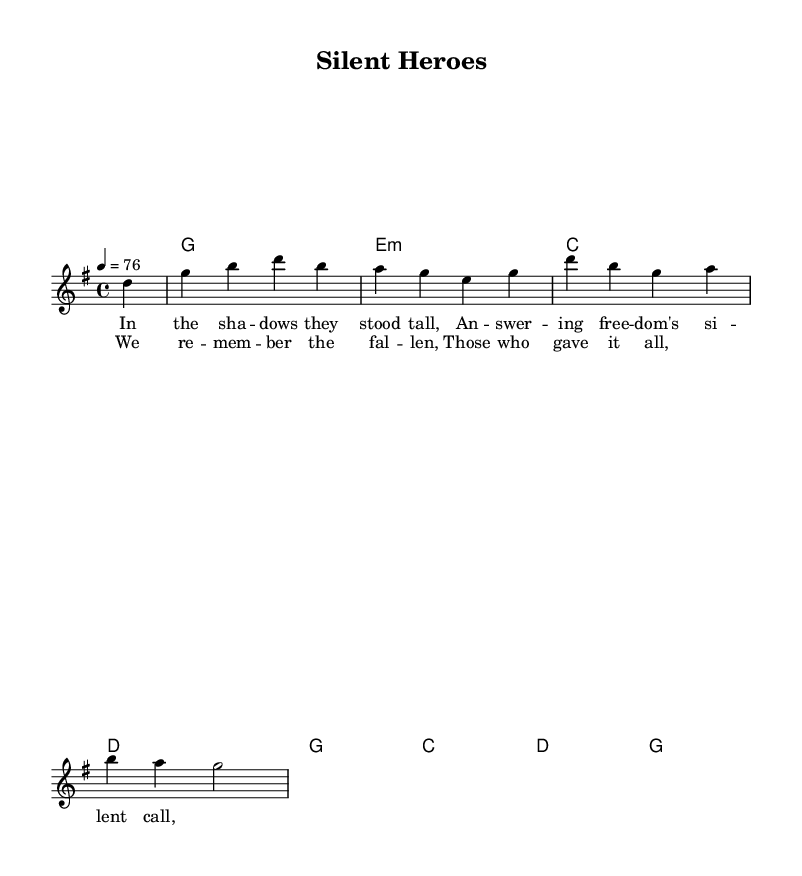What is the key signature of this music? The key signature of the music is G major, which contains one sharp (F#). This is determined by looking at the key signature marking at the beginning of the score.
Answer: G major What is the time signature of this music? The time signature of the music is 4/4, indicated by the '4' on top and the '4' on the bottom at the beginning of the score, meaning there are four beats per measure.
Answer: 4/4 What is the tempo marking for this piece? The tempo marking is 76 beats per minute, as given right after the time signature. This indicates the speed at which the piece should be played.
Answer: 76 How many measures are in the verse? The verse consists of four measures, which can be counted based on the grouping of the notes in the "melody" section. Each measure is separated by a vertical line in the notation.
Answer: 4 What is the main theme of the lyrics? The main theme revolves around honoring fallen operatives, as indicated in the lyrics of both the verse and the chorus, which mention remembrance and sacrifice. This thematic element is often central to patriotic country rock.
Answer: Honoring fallen operatives What chords accompany the chorus? The chords that accompany the chorus are C, D, and G, as outlined in the "harmonies" section, which aligns with the lyrical content of remembrance in the chorus.
Answer: C, D, G What is the style of this music? The style of the music is Country Rock, which is indicated by the genre context and the structure of the rhythms and harmonies that reflect this musical style.
Answer: Country Rock 